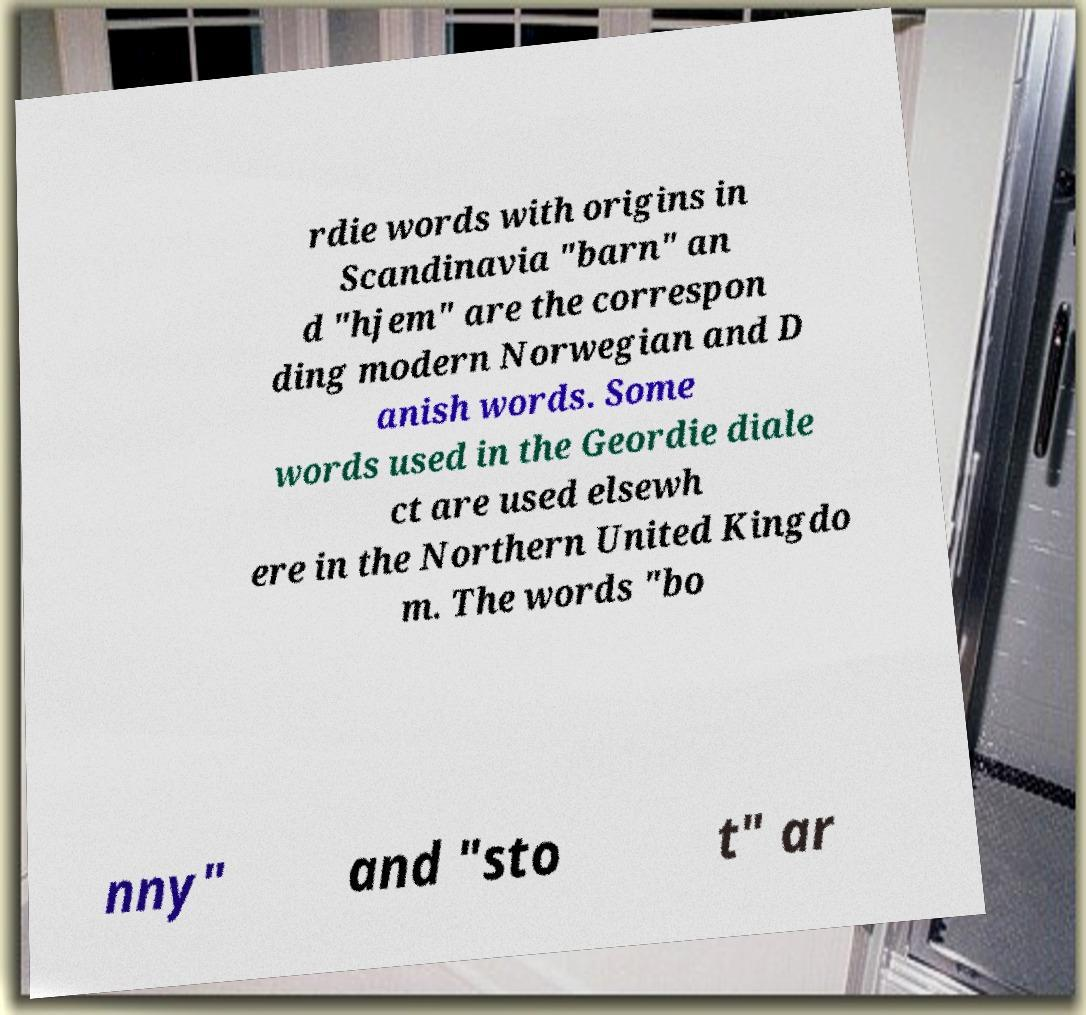Can you read and provide the text displayed in the image?This photo seems to have some interesting text. Can you extract and type it out for me? rdie words with origins in Scandinavia "barn" an d "hjem" are the correspon ding modern Norwegian and D anish words. Some words used in the Geordie diale ct are used elsewh ere in the Northern United Kingdo m. The words "bo nny" and "sto t" ar 